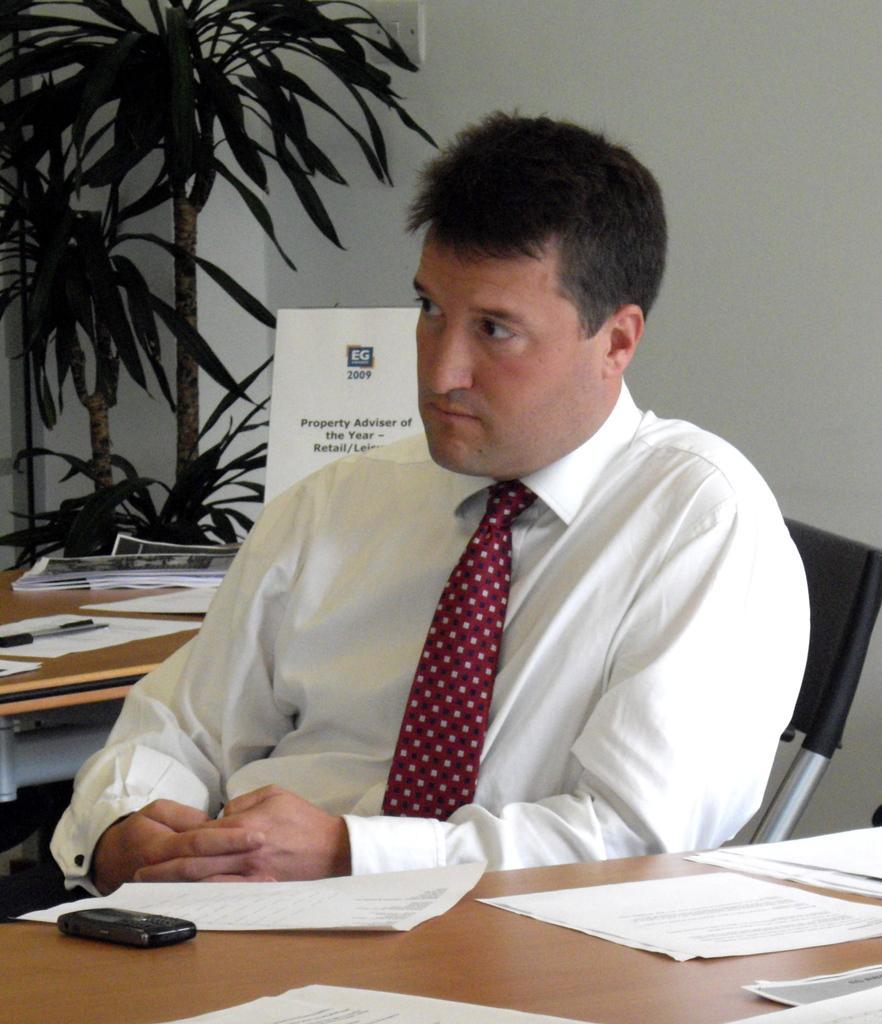How would you summarize this image in a sentence or two? Here I can see a man wearing white color shirt, sitting on the chair in front of the table and looking at the left side. On the table I can see few papers. At the back of this man there is another table on which there are some papers. At the back of it I can see two plants and in the background there is a wall. 